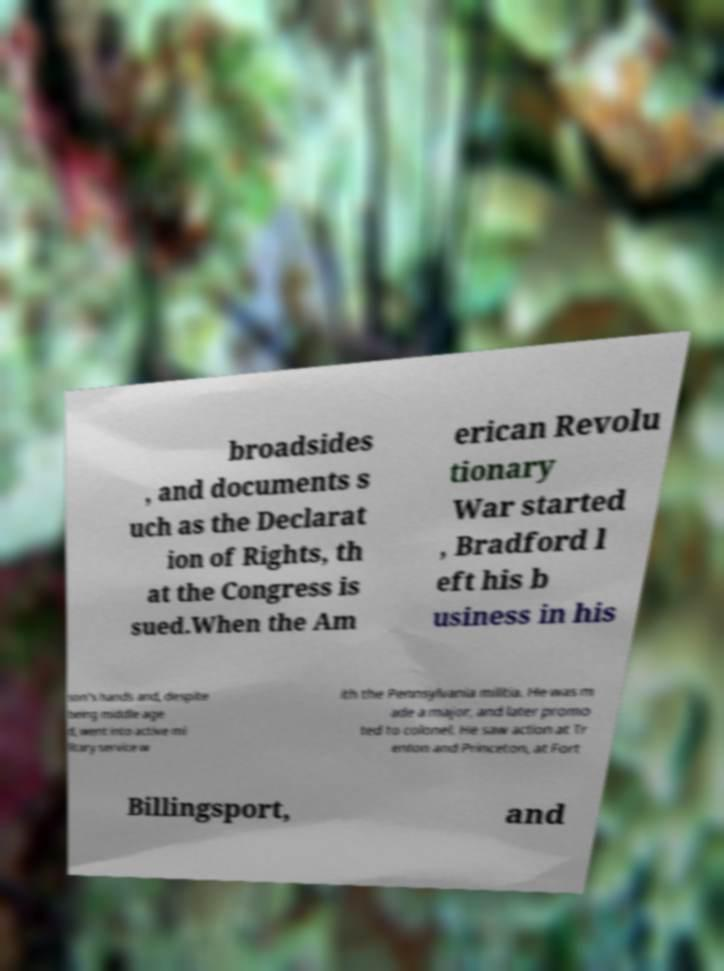What messages or text are displayed in this image? I need them in a readable, typed format. broadsides , and documents s uch as the Declarat ion of Rights, th at the Congress is sued.When the Am erican Revolu tionary War started , Bradford l eft his b usiness in his son's hands and, despite being middle age d, went into active mi litary service w ith the Pennsylvania militia. He was m ade a major, and later promo ted to colonel. He saw action at Tr enton and Princeton, at Fort Billingsport, and 